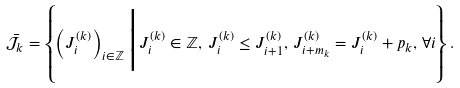<formula> <loc_0><loc_0><loc_500><loc_500>\bar { \mathcal { J } } _ { k } = \left \{ \left ( J ^ { ( k ) } _ { i } \right ) _ { i \in \mathbb { Z } } \Big | J ^ { ( k ) } _ { i } \in \mathbb { Z } , \, J ^ { ( k ) } _ { i } \leq J ^ { ( k ) } _ { i + 1 } , \, J ^ { ( k ) } _ { i + m _ { k } } = J ^ { ( k ) } _ { i } + p _ { k } , \, \forall i \right \} .</formula> 